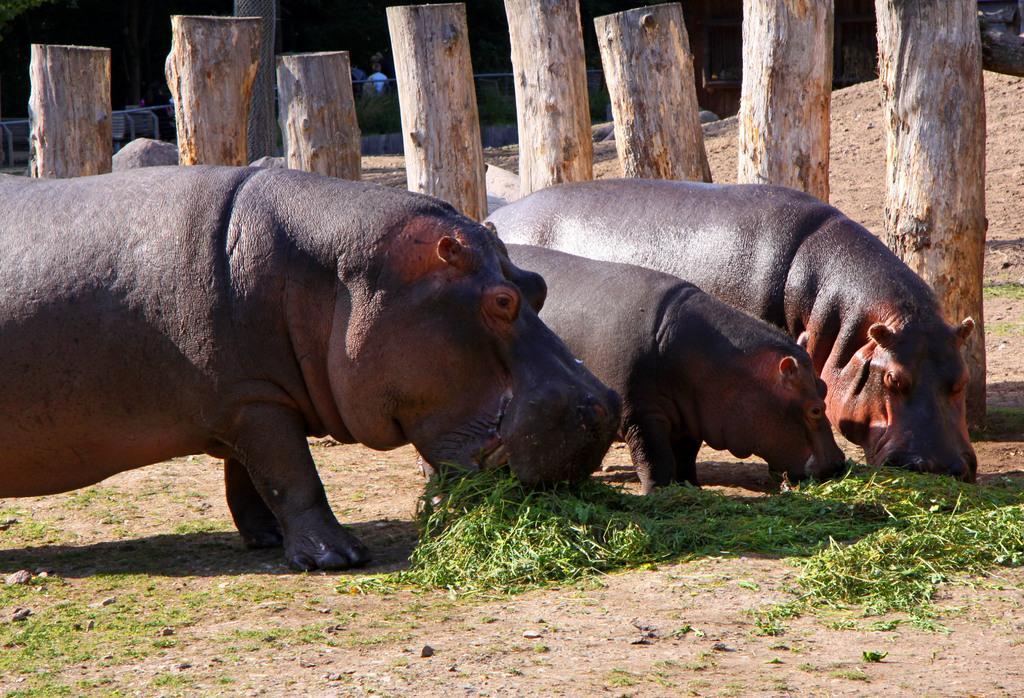In one or two sentences, can you explain what this image depicts? In this picture we can see three hippopotamuses standing and eating something, at the bottom there are some leaves of plants, in the background we can see wood and rocks, at the left bottom there is some grass. 